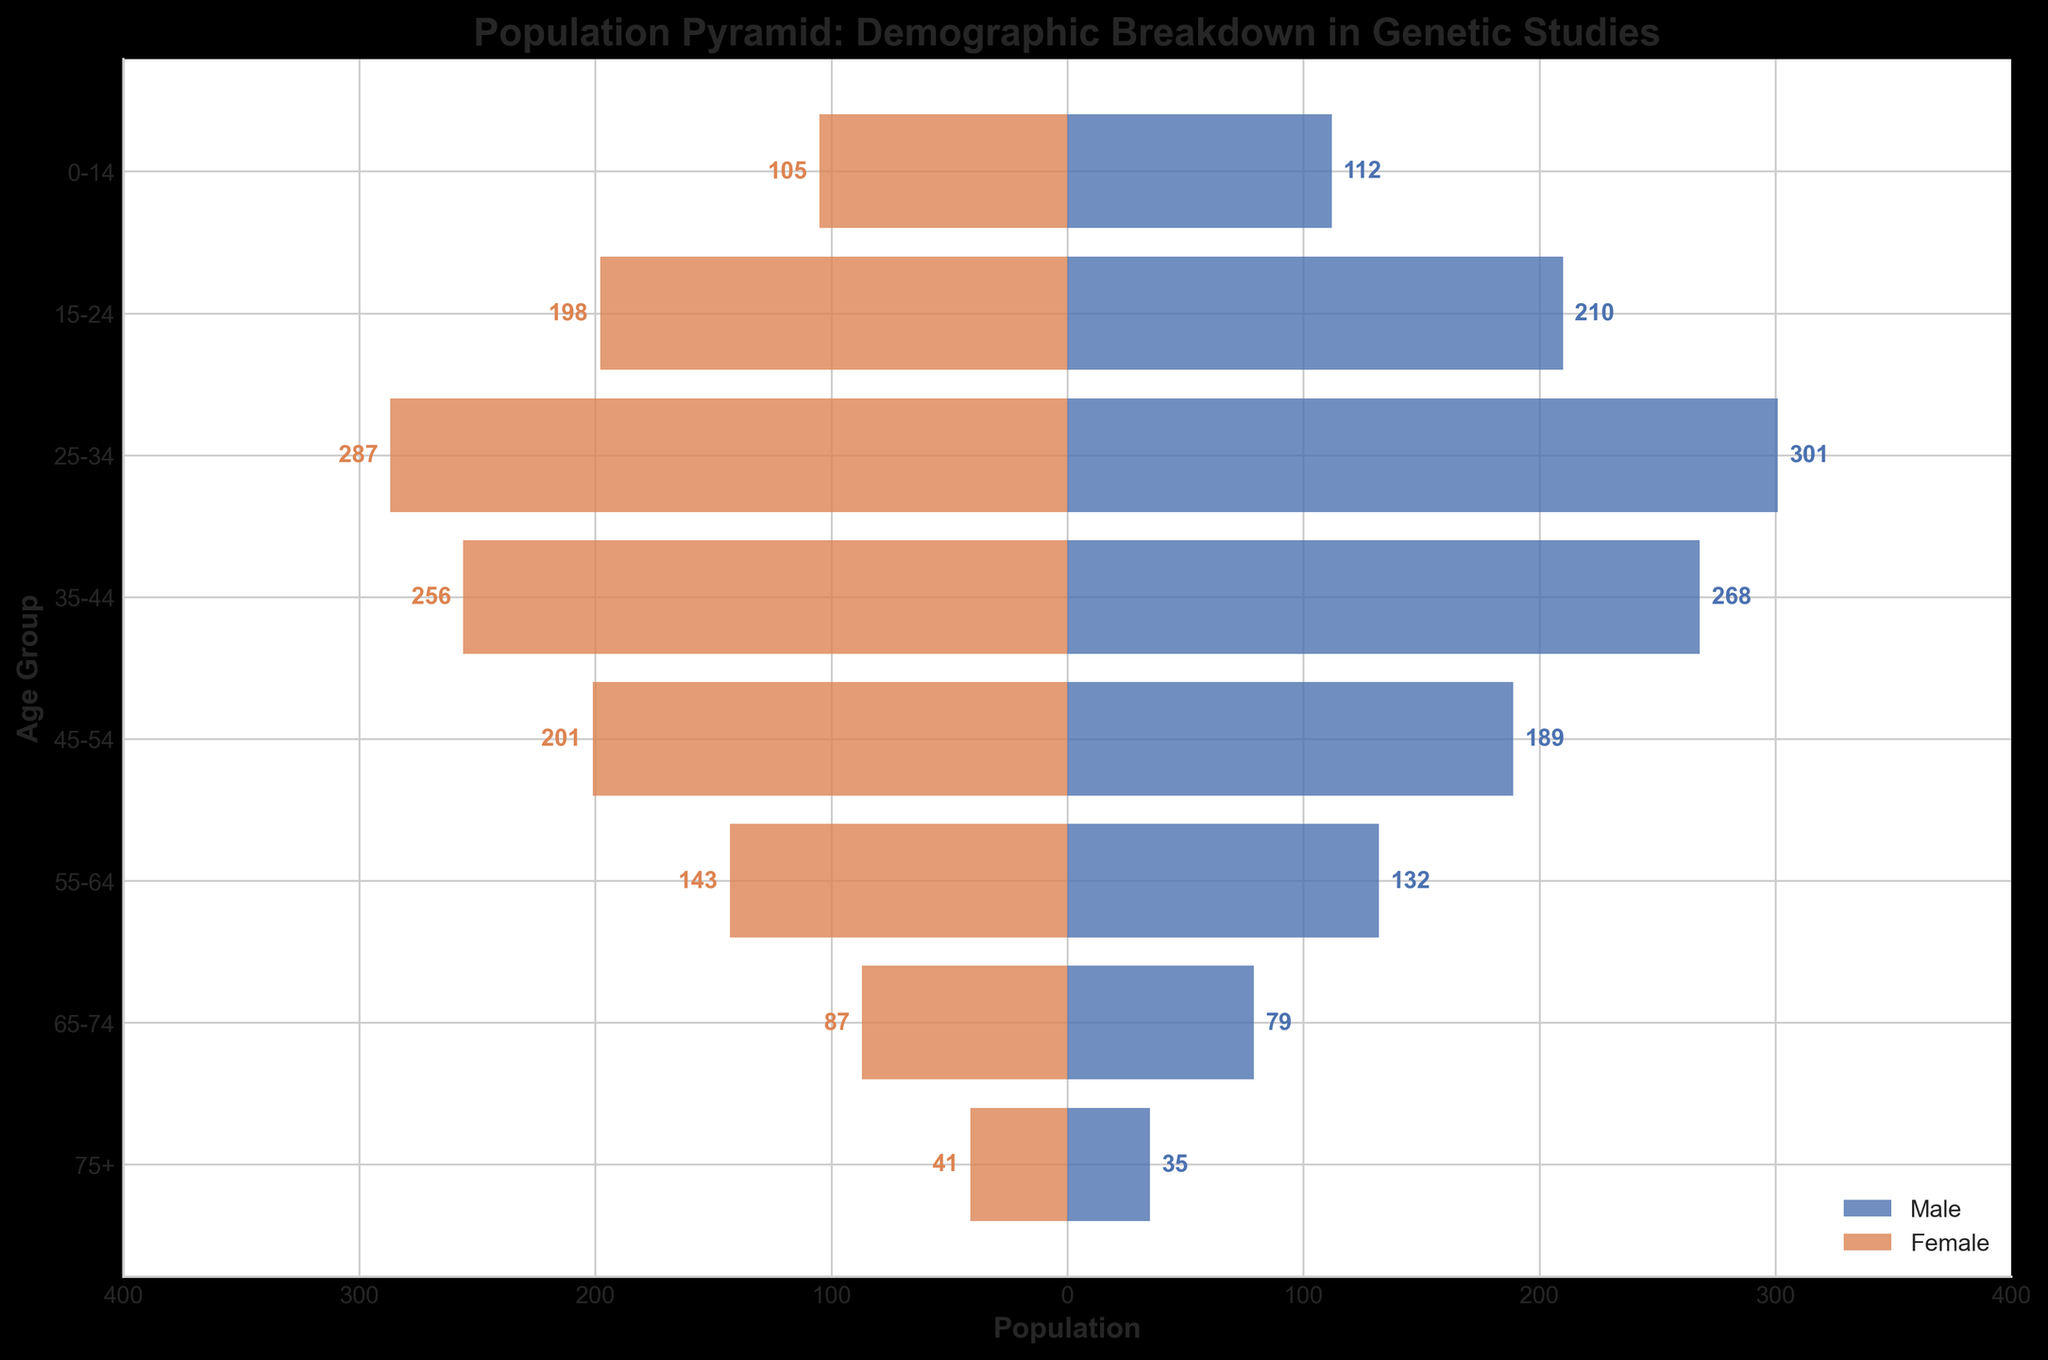Which age group has the highest number of female participants? By looking at the bar representing Female on the left side of the pyramid, the maximum length corresponds to the age group 25-34. Thus, this group has the highest number of female participants.
Answer: 25-34 Which age group has more male participants: 45-54 or 55-64? Compare the length of the bars representing Male on the right side of the pyramid. The 45-54 group has a longer bar than the 55-64 group, indicating more male participants.
Answer: 45-54 What's the total number of participants in the age group 0-14? Add the number of Female and Male participants in the age group 0-14: 105 + 112 = 217.
Answer: 217 How does the number of female participants in the age group 75+ compare to the number of male participants in the same age group? Compare the bars in the 75+ age group for Female and Male. The female participant bar (41) is longer than the male participant bar (35).
Answer: Females have more participants Calculate the difference in the number of participants between the age groups 25-34 and 35-44. Sum the number of participants for both age groups: (287 + 301) for 25-34 and (256 + 268) for 35-44. Then, calculate the difference: (287 + 301) - (256 + 268) = 588 - 524 = 64.
Answer: 64 Which age group has nearly equal numbers of male and female participants? Compare bars for both Male and Female. The age group 0-14 has nearly equal lengths for male (112) and female (105) participants.
Answer: 0-14 What is the average number of male participants across all age groups? Sum the male participant counts: 112 + 210 + 301 + 268 + 189 + 132 + 79 + 35 = 1326. Divide this by the number of age groups (8): 1326 / 8 = 165.75.
Answer: 165.75 Which age group has the fewest total participants, and what is that total? Add male and female participants for each age group and identify the smallest total. For 75+: 41 (female) + 35 (male) = 76. This is the smallest total.
Answer: 75+, 76 Is the number of male participants in the age group 15-24 greater than the number of female participants in the age group 35-44? Compare the number of male participants in 15-24 (210) with the number of female participants in 35-44 (256). 210 is less than 256.
Answer: No 